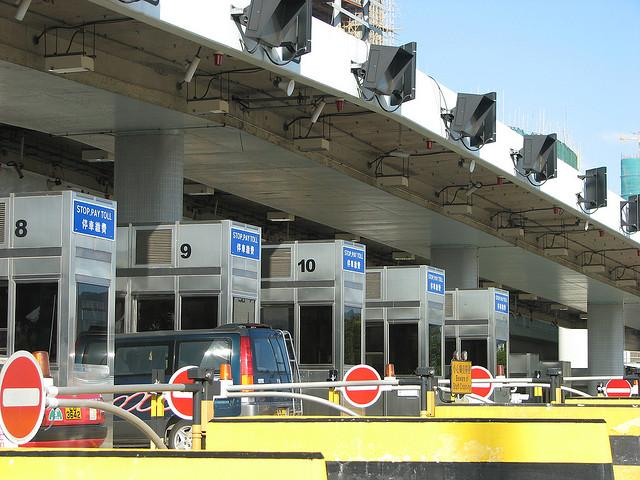What does the red sign with a minus symbol on it usually mean? Please explain your reasoning. no entering. The sign means no entering. 